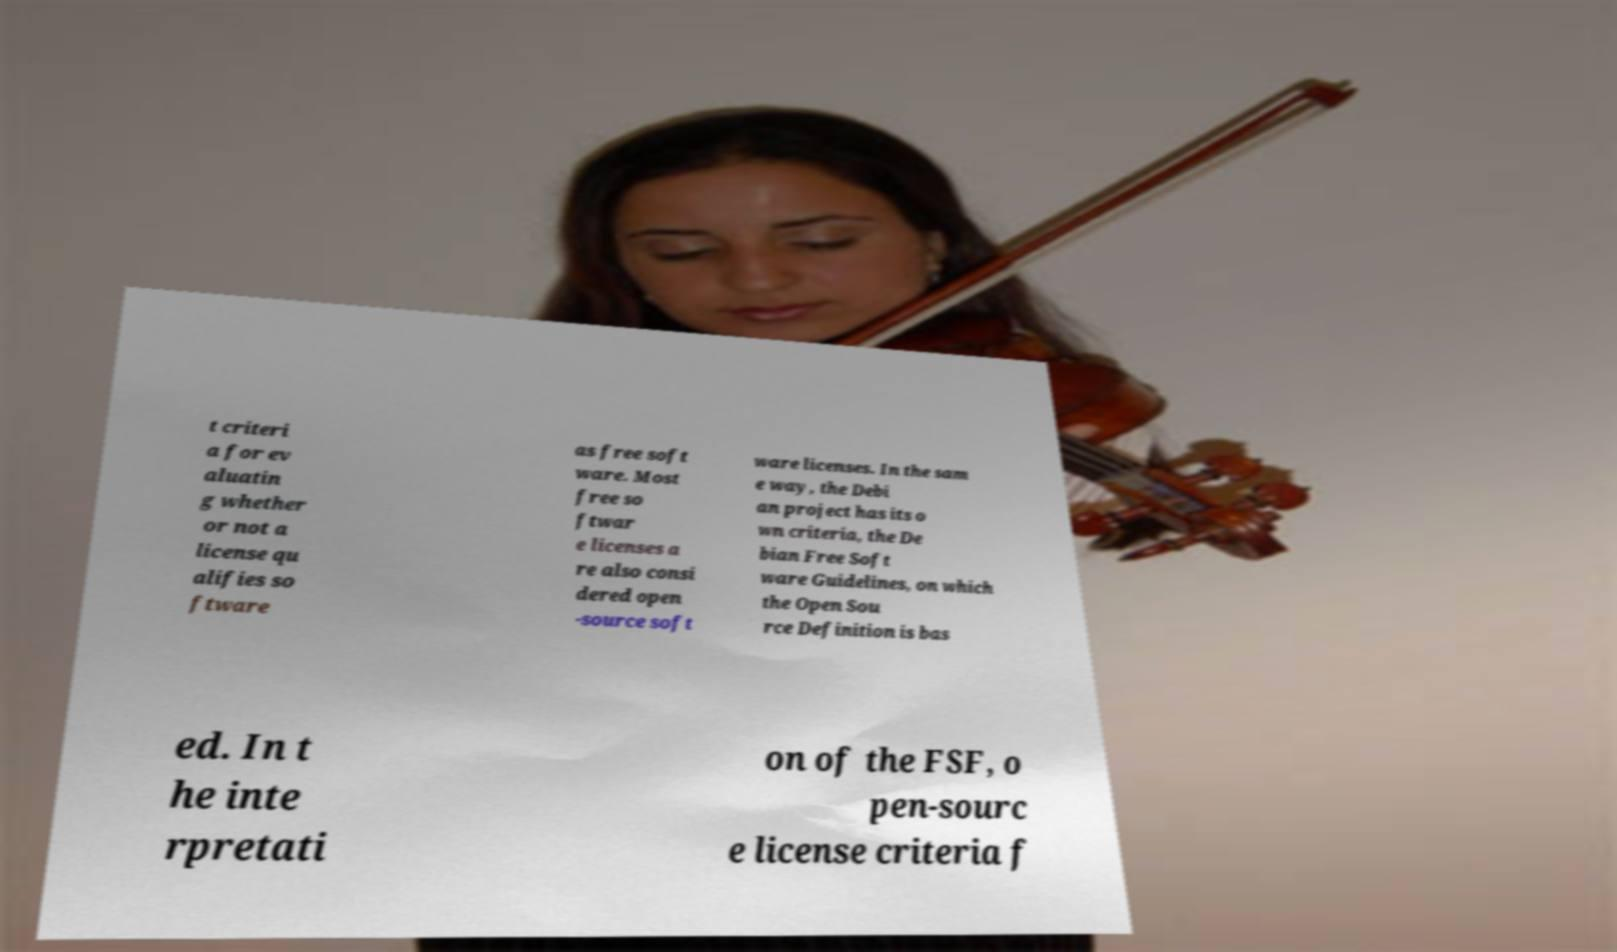There's text embedded in this image that I need extracted. Can you transcribe it verbatim? t criteri a for ev aluatin g whether or not a license qu alifies so ftware as free soft ware. Most free so ftwar e licenses a re also consi dered open -source soft ware licenses. In the sam e way, the Debi an project has its o wn criteria, the De bian Free Soft ware Guidelines, on which the Open Sou rce Definition is bas ed. In t he inte rpretati on of the FSF, o pen-sourc e license criteria f 